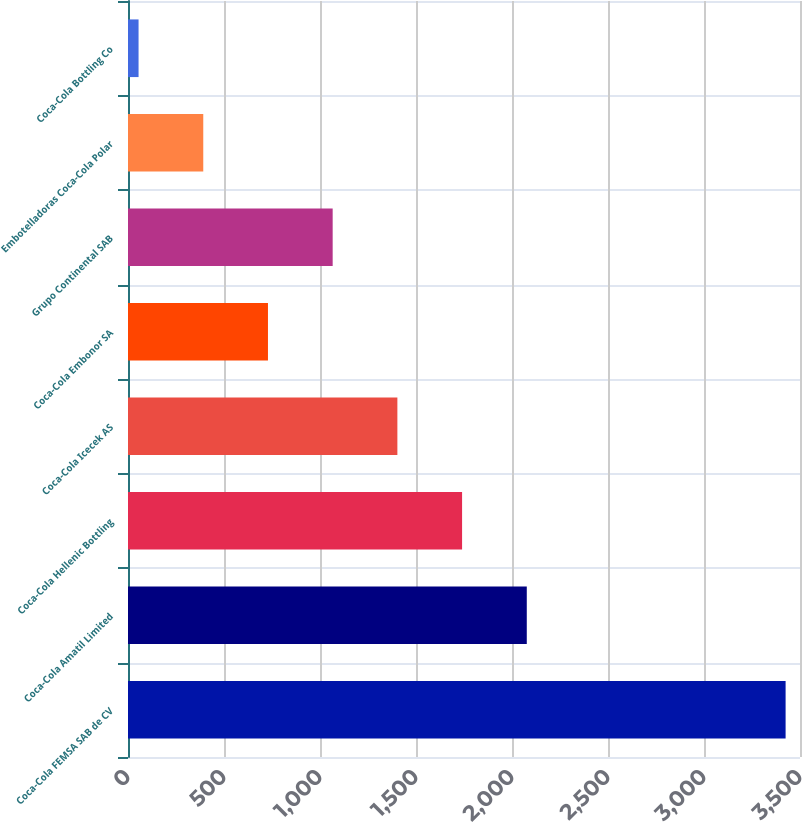<chart> <loc_0><loc_0><loc_500><loc_500><bar_chart><fcel>Coca-Cola FEMSA SAB de CV<fcel>Coca-Cola Amatil Limited<fcel>Coca-Cola Hellenic Bottling<fcel>Coca-Cola Icecek AS<fcel>Coca-Cola Embonor SA<fcel>Grupo Continental SAB<fcel>Embotelladoras Coca-Cola Polar<fcel>Coca-Cola Bottling Co<nl><fcel>3425<fcel>2077<fcel>1740<fcel>1403<fcel>729<fcel>1066<fcel>392<fcel>55<nl></chart> 